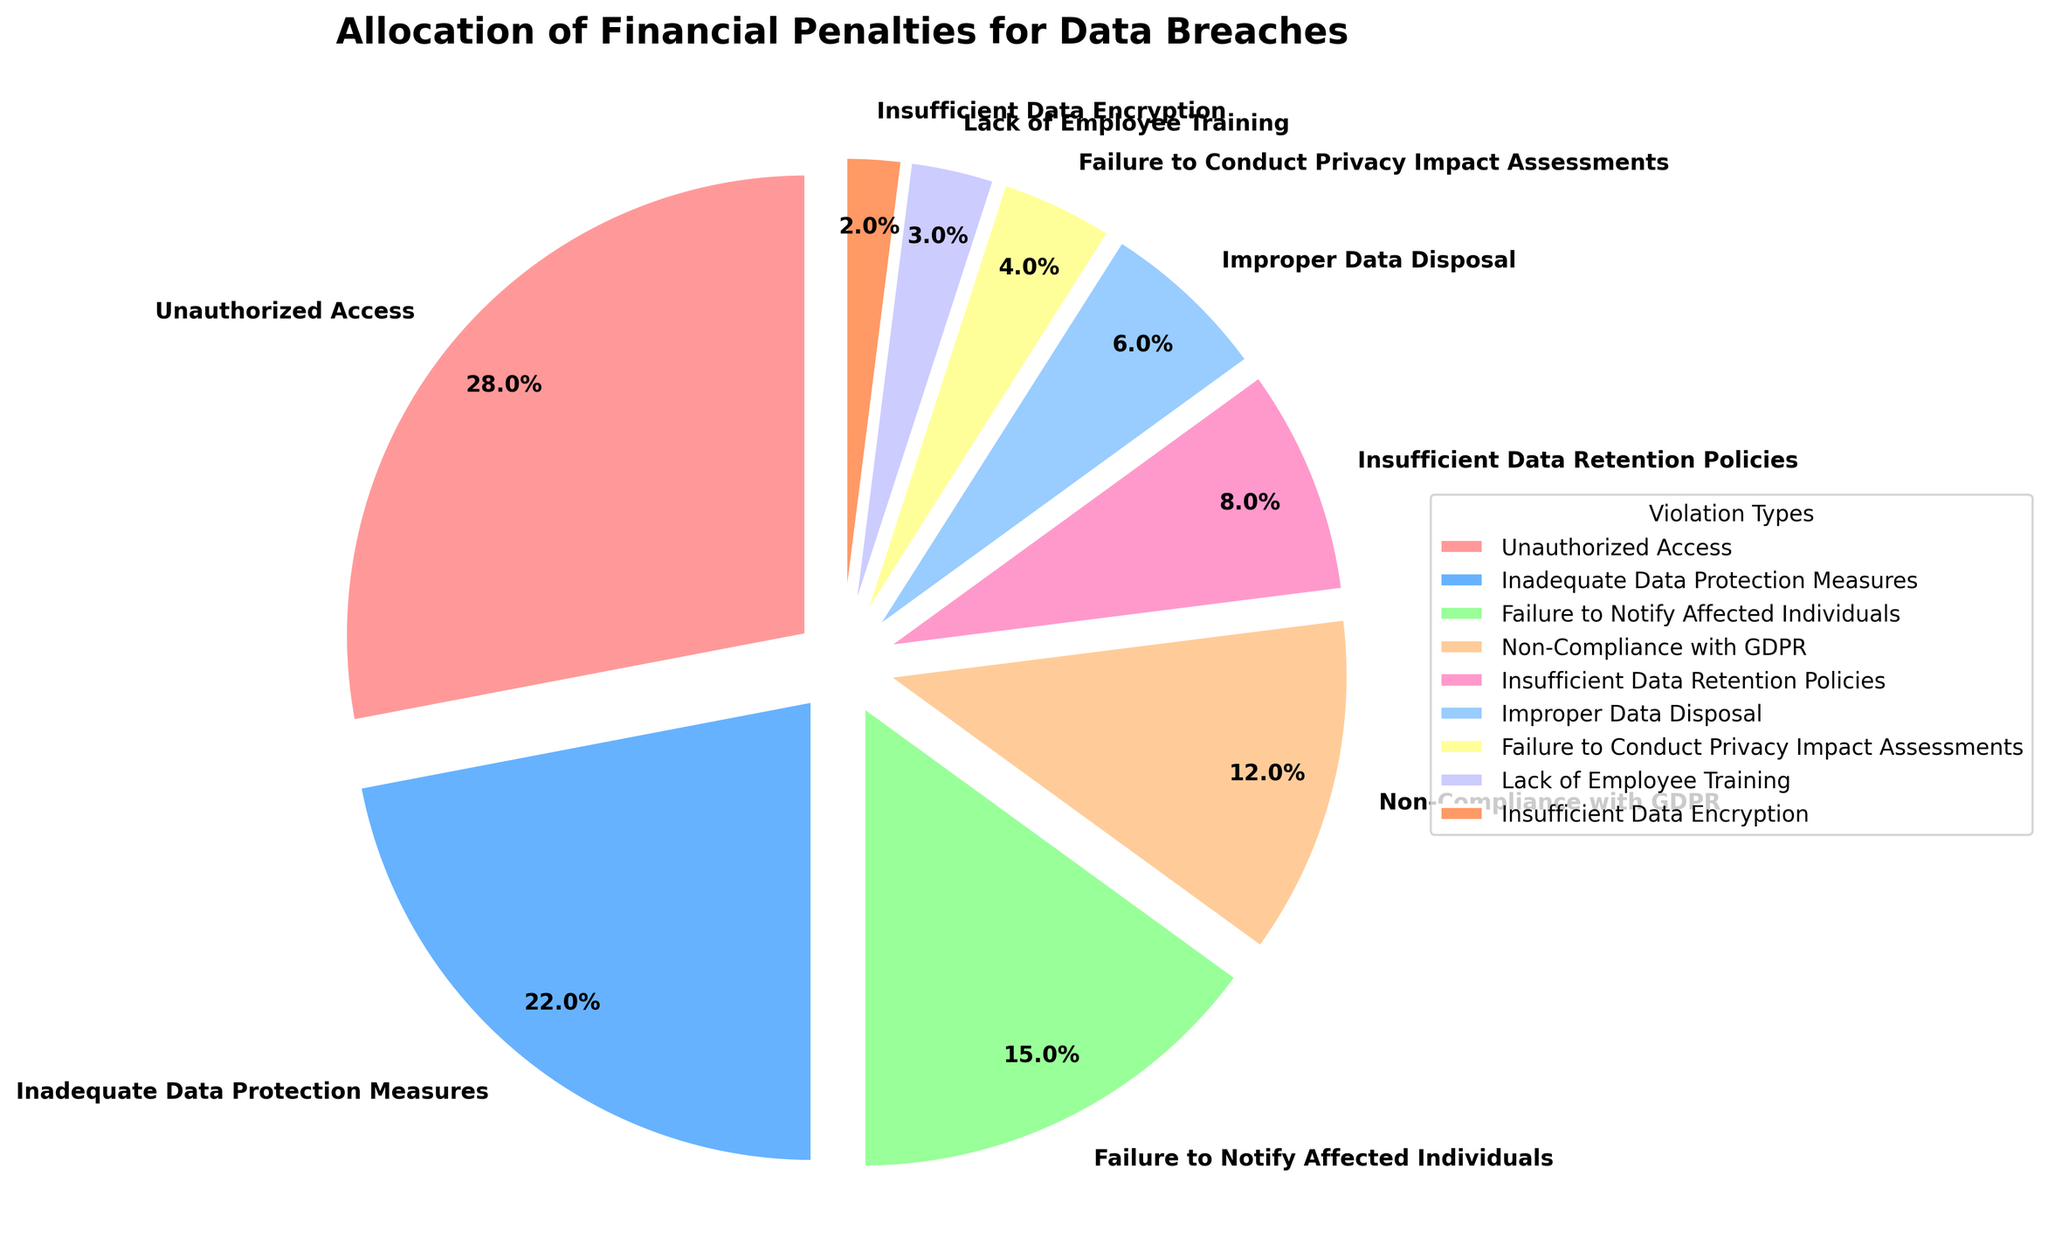What is the percentage of penalties for Unauthorized Access violations? The pie chart shows that the portion associated with Unauthorized Access violations has a percentage value of 28%.
Answer: 28% Which violation type has the smallest percentage of penalties? By looking at the pie chart, Insufficient Data Encryption has the smallest slice, with a percentage value of 2%.
Answer: Insufficient Data Encryption How much larger is the percentage of Unauthorized Access penalties compared to that for Inadequate Data Protection Measures? The percentage for Unauthorized Access is 28%, and for Inadequate Data Protection Measures, it is 22%. The difference is 28% - 22% = 6%.
Answer: 6% What is the combined percentage of penalties for Failure to Conduct Privacy Impact Assessments and Lack of Employee Training? The percentage for Failure to Conduct Privacy Impact Assessments is 4%, and for Lack of Employee Training, it is 3%. The combined percentage is 4% + 3% = 7%.
Answer: 7% Do Unauthorized Access and Inadequate Data Protection Measures together make up more than half of the penalties? Unauthorized Access has 28% and Inadequate Data Protection Measures has 22%. Combined, their total is 28% + 22% = 50%. Since 50% is exactly half, they do not make up more than half.
Answer: No Which violation type has the second-highest percentage of penalties? The pie chart shows Unauthorized Access as the highest with 28%, and Inadequate Data Protection Measures as the second-highest with 22%.
Answer: Inadequate Data Protection Measures What is the percentage difference between Non-Compliance with GDPR and Insufficient Data Retention Policies? The percentage for Non-Compliance with GDPR is 12%, while Insufficient Data Retention Policies is 8%. The difference is 12% - 8% = 4%.
Answer: 4% Which color is used to represent the penalties for Non-Compliance with GDPR? The pie chart uses different colors for each category, and Non-Compliance with GDPR is represented by the green slice.
Answer: Green If the percentage for Unauthorized Access were increased by 5%, what would be the new value? The current percentage for Unauthorized Access is 28%. If increased by 5%, the new value would be 28% + 5% = 33%.
Answer: 33% Is the penalty percentage for Improper Data Disposal greater than that for Insufficient Data Retention Policies? The pie chart shows that Improper Data Disposal has a percentage of 6% and Insufficient Data Retention Policies has a percentage of 8%, so Improper Data Disposal is not greater.
Answer: No 